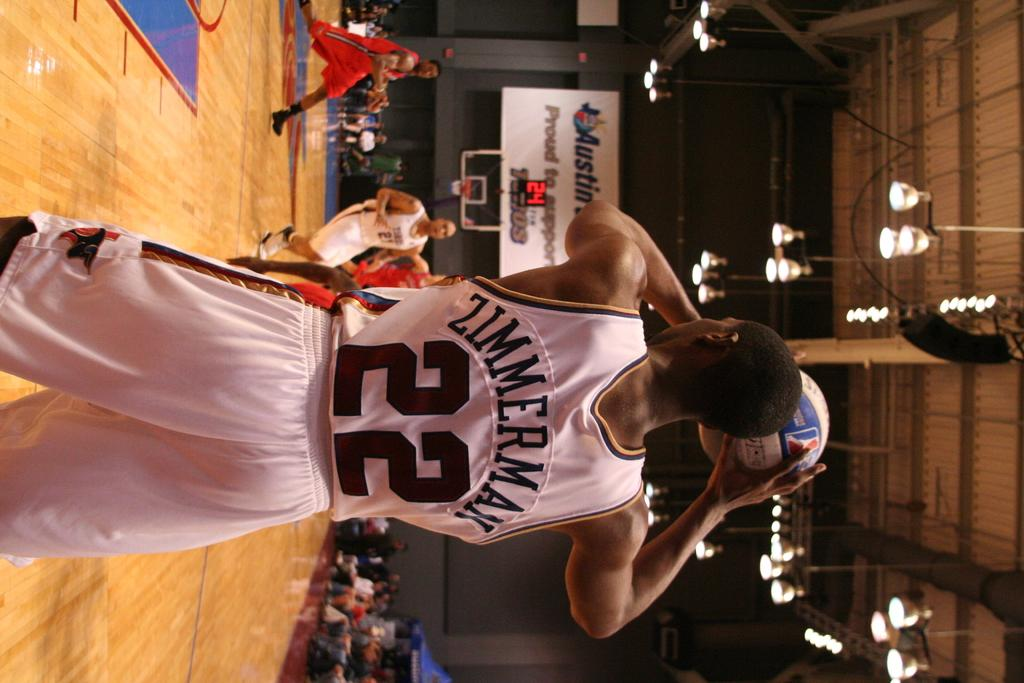Provide a one-sentence caption for the provided image. A basketball player named Zimmerman on the court ready to shoot the ball. 